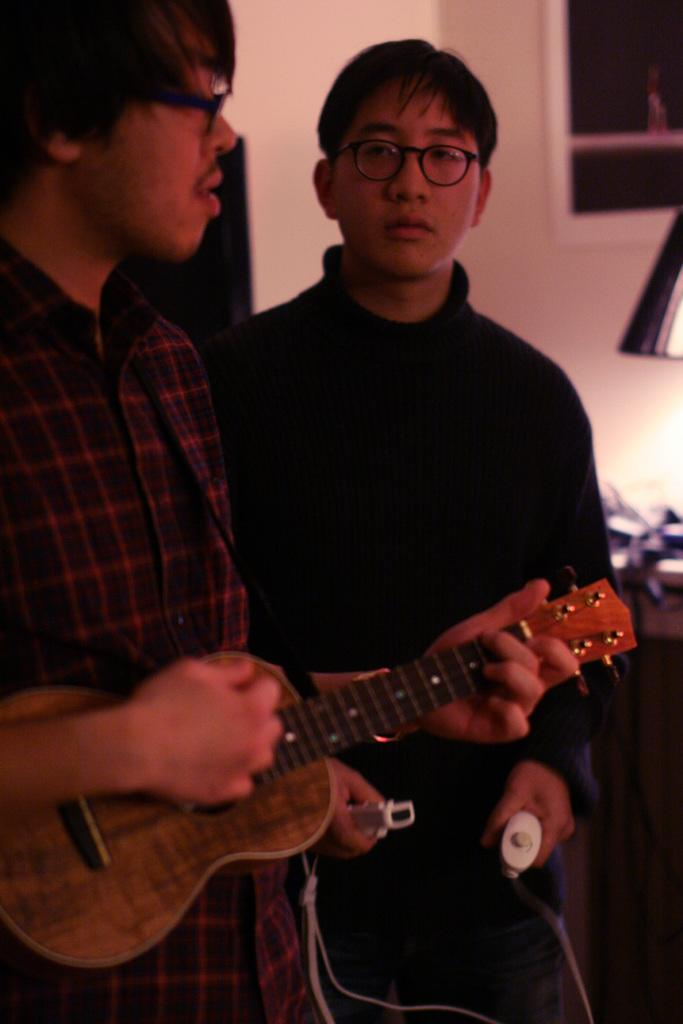How many people are in the image? There are two guys in the image. What is one of the guys doing in the image? One of the guys is playing a guitar. Can you describe the shirt worn by the guitar player? The guitar player is wearing a red check shirt. What is the other guy doing in the image? The other guy is standing beside the guitar player. How is the second guy positioned in relation to the camera? The second guy is looking straight at the camera. What type of kite is the guitar player holding in the image? There is no kite present in the image; the guitar player is holding a guitar. Can you tell me how many wires are connected to the guitar? The image does not provide enough detail to determine the number of wires connected to the guitar. 